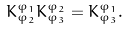<formula> <loc_0><loc_0><loc_500><loc_500>K _ { { \varphi } _ { 2 } } ^ { { \varphi } _ { 1 } } K _ { { \varphi } _ { 3 } } ^ { { \varphi } _ { 2 } } = K _ { { \varphi } _ { 3 } } ^ { { \varphi } _ { 1 } } .</formula> 